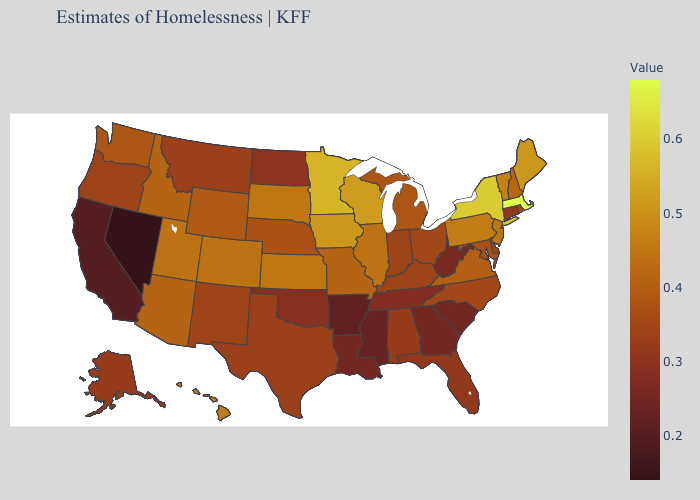Does North Dakota have the lowest value in the MidWest?
Concise answer only. Yes. Does the map have missing data?
Write a very short answer. No. Does Nevada have the lowest value in the USA?
Answer briefly. Yes. 